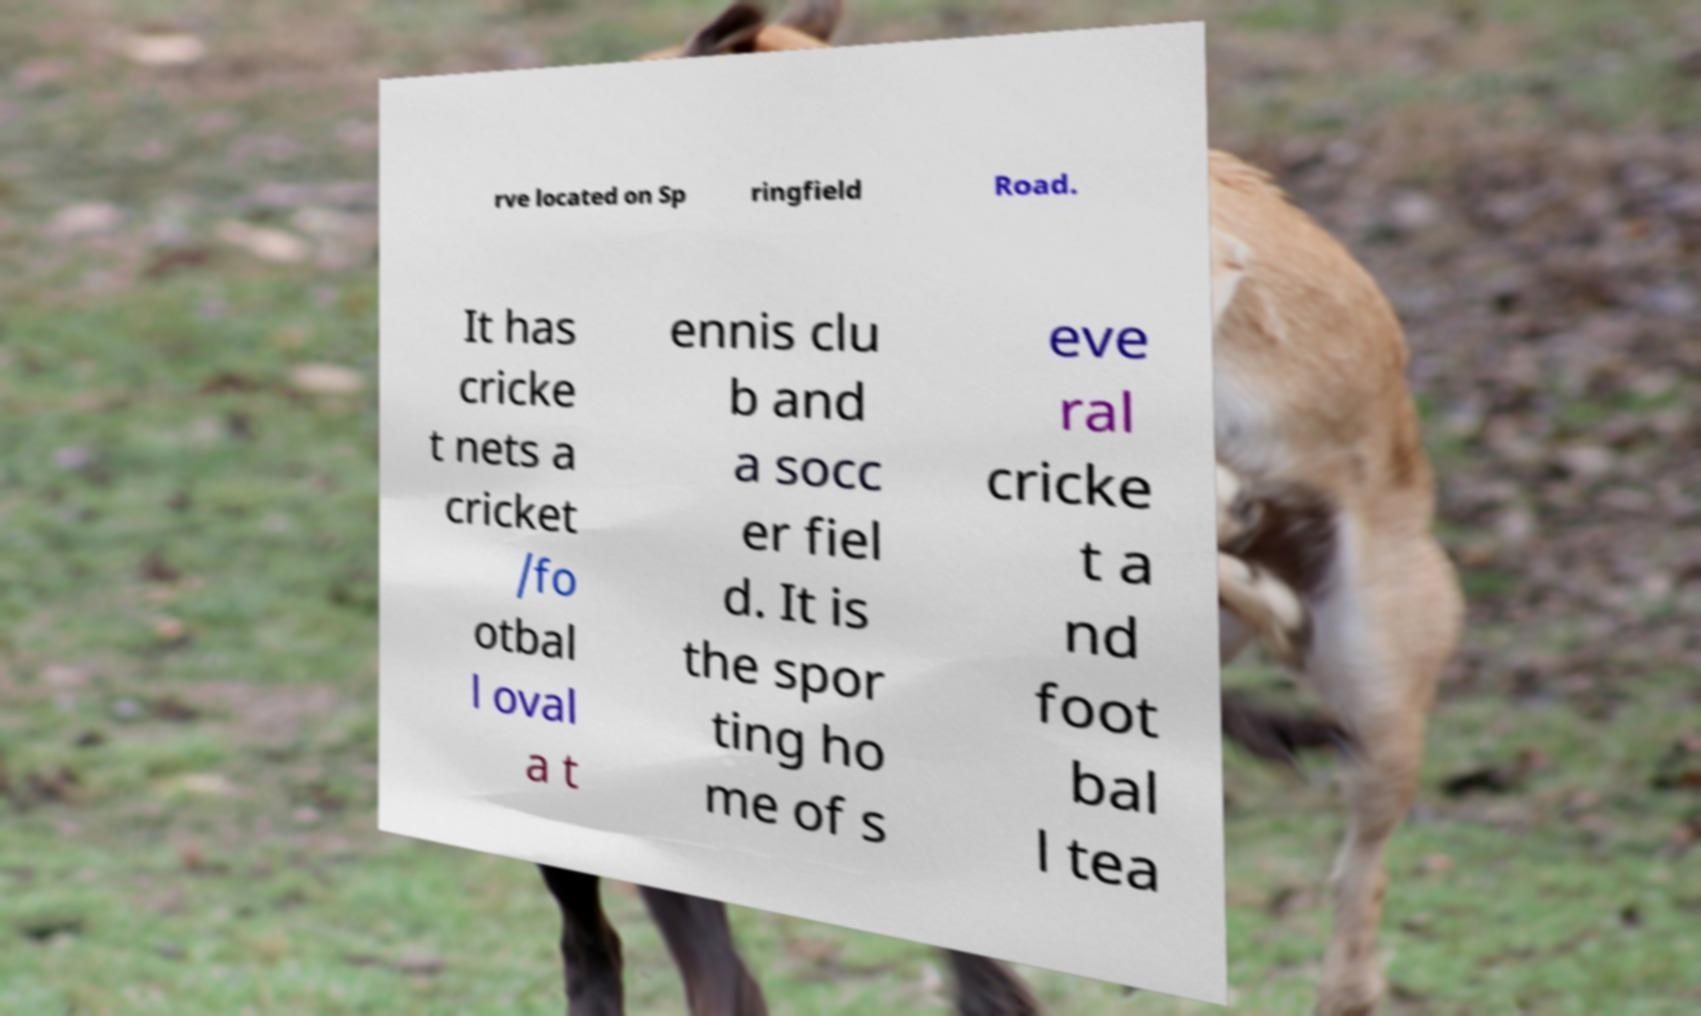Can you accurately transcribe the text from the provided image for me? rve located on Sp ringfield Road. It has cricke t nets a cricket /fo otbal l oval a t ennis clu b and a socc er fiel d. It is the spor ting ho me of s eve ral cricke t a nd foot bal l tea 